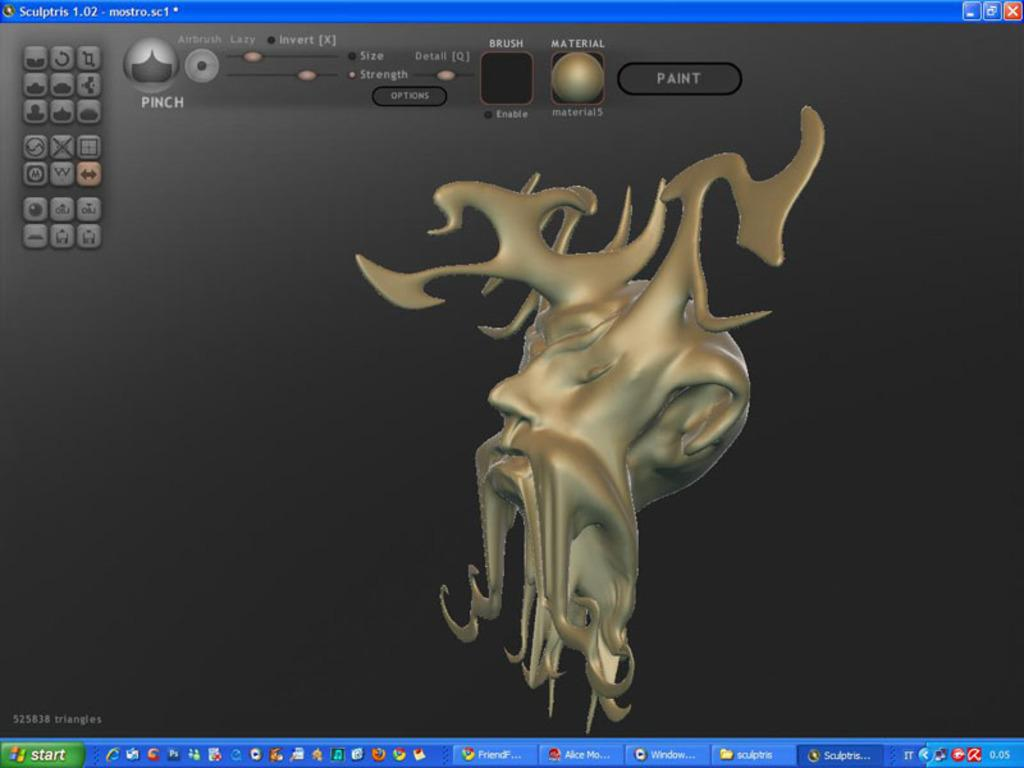<image>
Describe the image concisely. A computer screen shows the program Sculptris open. 